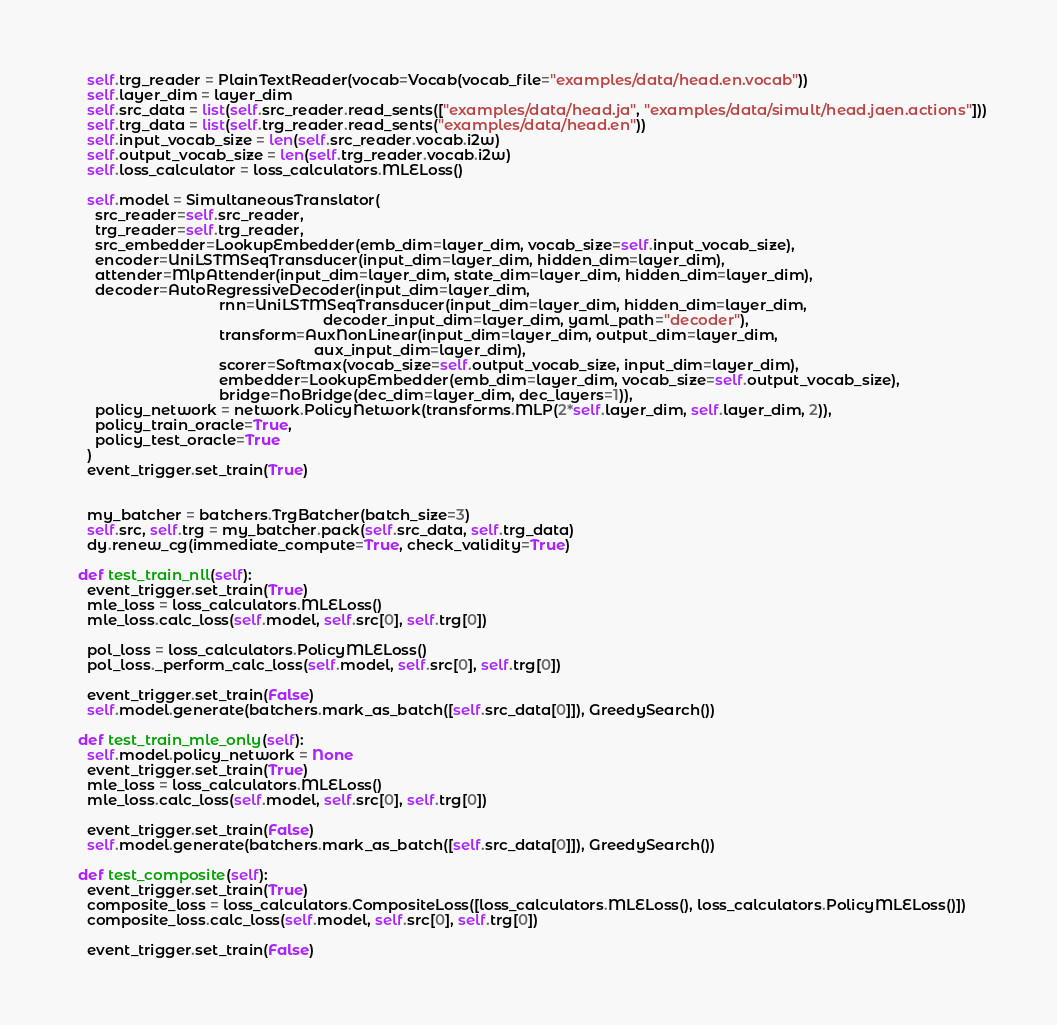<code> <loc_0><loc_0><loc_500><loc_500><_Python_>    self.trg_reader = PlainTextReader(vocab=Vocab(vocab_file="examples/data/head.en.vocab"))
    self.layer_dim = layer_dim
    self.src_data = list(self.src_reader.read_sents(["examples/data/head.ja", "examples/data/simult/head.jaen.actions"]))
    self.trg_data = list(self.trg_reader.read_sents("examples/data/head.en"))
    self.input_vocab_size = len(self.src_reader.vocab.i2w)
    self.output_vocab_size = len(self.trg_reader.vocab.i2w)
    self.loss_calculator = loss_calculators.MLELoss()
    
    self.model = SimultaneousTranslator(
      src_reader=self.src_reader,
      trg_reader=self.trg_reader,
      src_embedder=LookupEmbedder(emb_dim=layer_dim, vocab_size=self.input_vocab_size),
      encoder=UniLSTMSeqTransducer(input_dim=layer_dim, hidden_dim=layer_dim),
      attender=MlpAttender(input_dim=layer_dim, state_dim=layer_dim, hidden_dim=layer_dim),
      decoder=AutoRegressiveDecoder(input_dim=layer_dim,
                                    rnn=UniLSTMSeqTransducer(input_dim=layer_dim, hidden_dim=layer_dim,
                                                             decoder_input_dim=layer_dim, yaml_path="decoder"),
                                    transform=AuxNonLinear(input_dim=layer_dim, output_dim=layer_dim,
                                                           aux_input_dim=layer_dim),
                                    scorer=Softmax(vocab_size=self.output_vocab_size, input_dim=layer_dim),
                                    embedder=LookupEmbedder(emb_dim=layer_dim, vocab_size=self.output_vocab_size),
                                    bridge=NoBridge(dec_dim=layer_dim, dec_layers=1)),
      policy_network = network.PolicyNetwork(transforms.MLP(2*self.layer_dim, self.layer_dim, 2)),
      policy_train_oracle=True,
      policy_test_oracle=True
    )
    event_trigger.set_train(True)
    

    my_batcher = batchers.TrgBatcher(batch_size=3)
    self.src, self.trg = my_batcher.pack(self.src_data, self.trg_data)
    dy.renew_cg(immediate_compute=True, check_validity=True)
    
  def test_train_nll(self):
    event_trigger.set_train(True)
    mle_loss = loss_calculators.MLELoss()
    mle_loss.calc_loss(self.model, self.src[0], self.trg[0])
    
    pol_loss = loss_calculators.PolicyMLELoss()
    pol_loss._perform_calc_loss(self.model, self.src[0], self.trg[0])

    event_trigger.set_train(False)
    self.model.generate(batchers.mark_as_batch([self.src_data[0]]), GreedySearch())
   
  def test_train_mle_only(self):
    self.model.policy_network = None
    event_trigger.set_train(True)
    mle_loss = loss_calculators.MLELoss()
    mle_loss.calc_loss(self.model, self.src[0], self.trg[0])
    
    event_trigger.set_train(False)
    self.model.generate(batchers.mark_as_batch([self.src_data[0]]), GreedySearch())

  def test_composite(self):
    event_trigger.set_train(True)
    composite_loss = loss_calculators.CompositeLoss([loss_calculators.MLELoss(), loss_calculators.PolicyMLELoss()])
    composite_loss.calc_loss(self.model, self.src[0], self.trg[0])
    
    event_trigger.set_train(False)</code> 